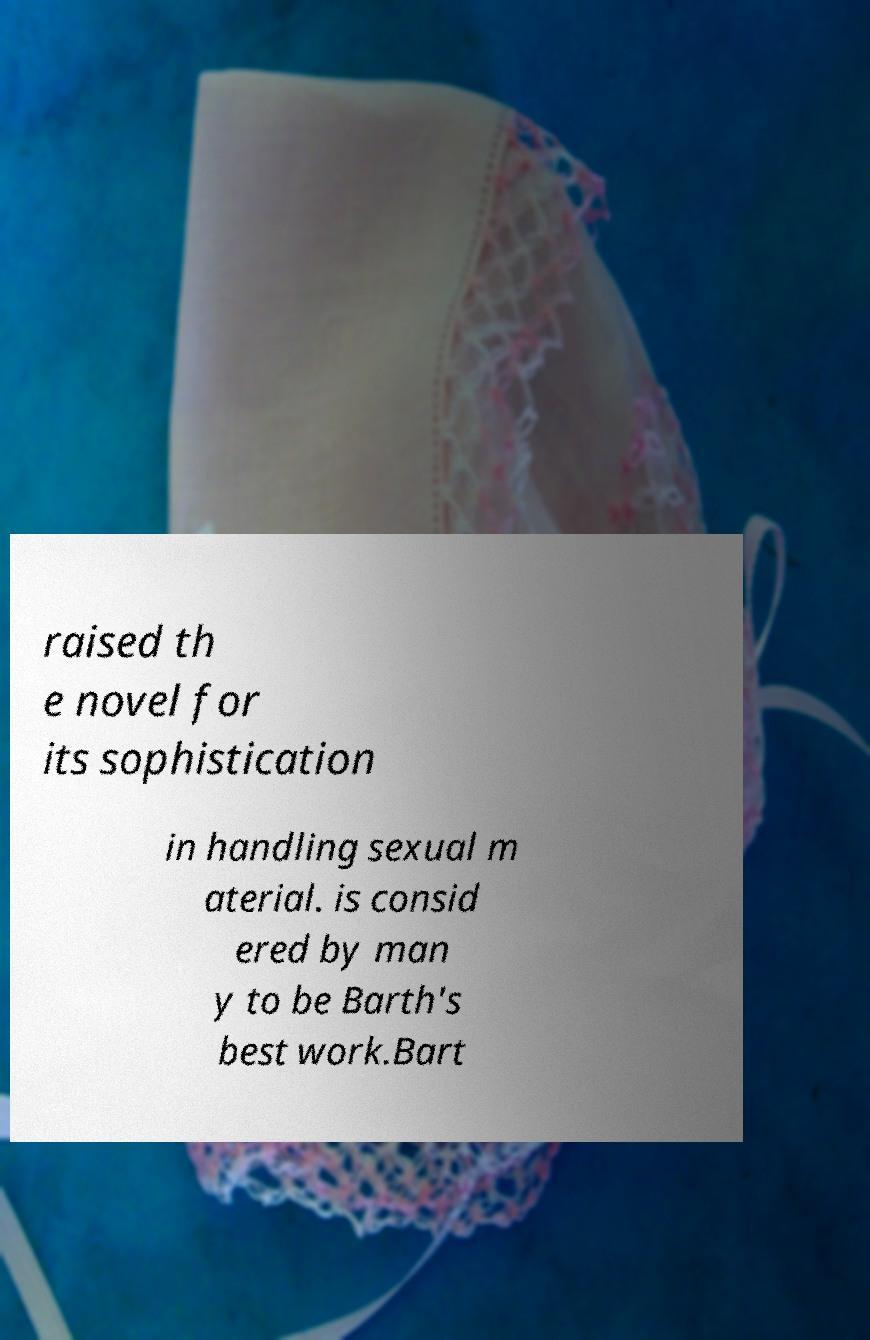Can you read and provide the text displayed in the image?This photo seems to have some interesting text. Can you extract and type it out for me? raised th e novel for its sophistication in handling sexual m aterial. is consid ered by man y to be Barth's best work.Bart 